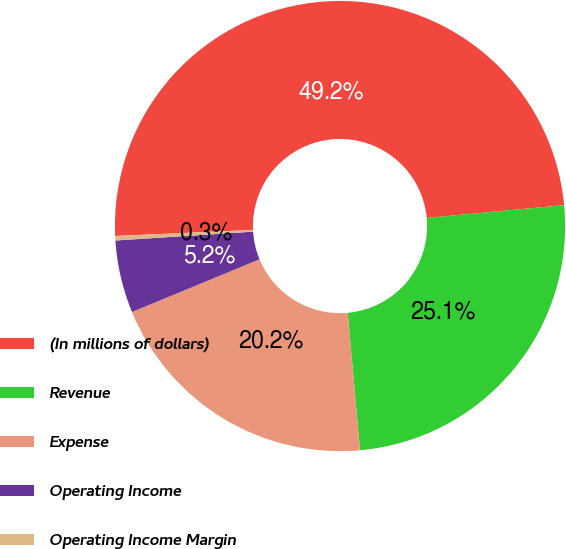<chart> <loc_0><loc_0><loc_500><loc_500><pie_chart><fcel>(In millions of dollars)<fcel>Revenue<fcel>Expense<fcel>Operating Income<fcel>Operating Income Margin<nl><fcel>49.22%<fcel>25.07%<fcel>20.18%<fcel>5.21%<fcel>0.32%<nl></chart> 